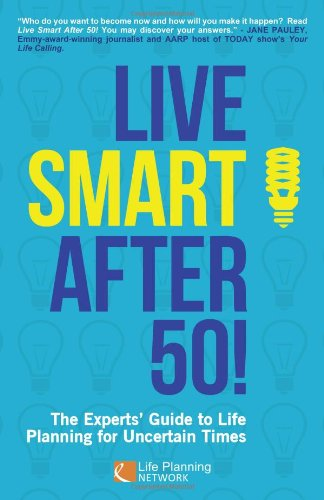What is the title of this book? The title of the book illustrated in the image is 'Live Smart After 50!'. 